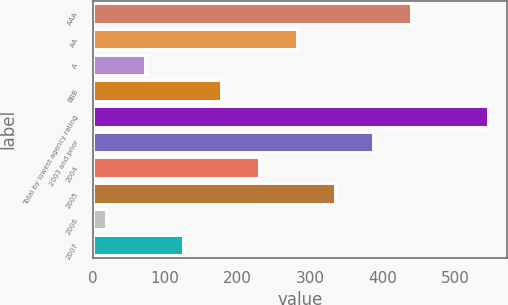Convert chart to OTSL. <chart><loc_0><loc_0><loc_500><loc_500><bar_chart><fcel>AAA<fcel>AA<fcel>A<fcel>BBB<fcel>Total by lowest agency rating<fcel>2003 and prior<fcel>2004<fcel>2005<fcel>2006<fcel>2007<nl><fcel>439.84<fcel>281.95<fcel>71.43<fcel>176.69<fcel>545.1<fcel>387.21<fcel>229.32<fcel>334.58<fcel>18.8<fcel>124.06<nl></chart> 